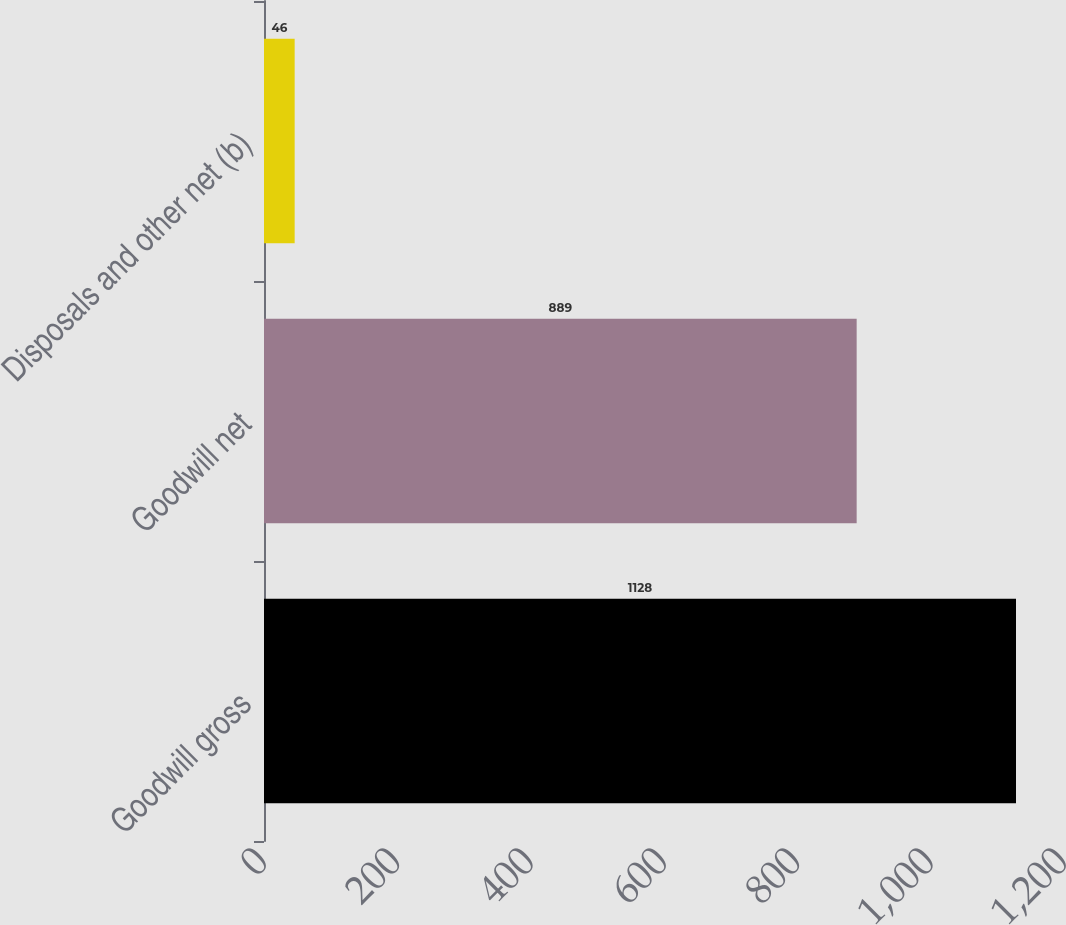<chart> <loc_0><loc_0><loc_500><loc_500><bar_chart><fcel>Goodwill gross<fcel>Goodwill net<fcel>Disposals and other net (b)<nl><fcel>1128<fcel>889<fcel>46<nl></chart> 